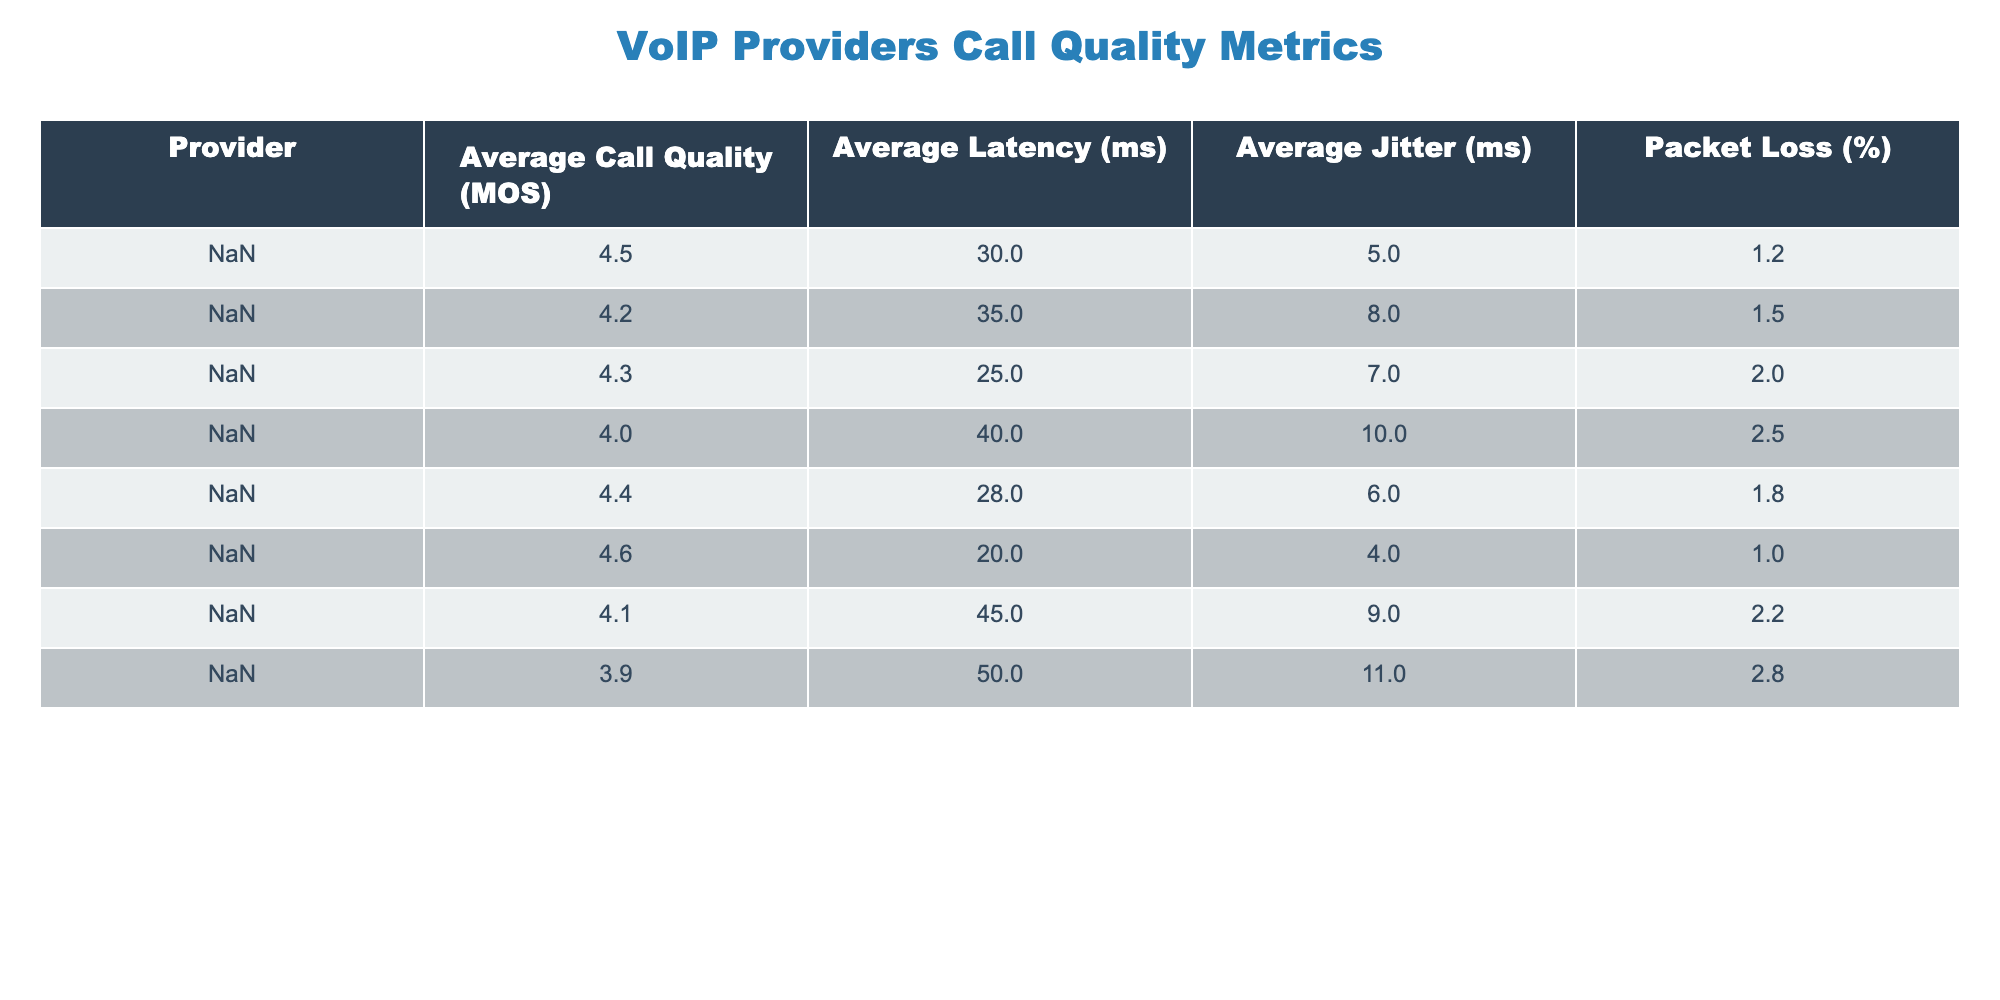What is the average call quality (MOS) of Zoom? According to the table, Zoom has an Average Call Quality (MOS) of 4.5. This value is directly available in the "Average Call Quality (MOS)" column under the Zoom row.
Answer: 4.5 Which VoIP provider has the highest packet loss percentage? The "Packet Loss (%)" column shows that Google Voice has the highest packet loss at 2.8%, as observed in the last row of the table.
Answer: Google Voice What is the average latency of Microsoft Teams? The average latency for Microsoft Teams can be found in the "Average Latency (ms)" column, where it shows a value of 28 milliseconds. This information is directly taken from the corresponding row for Microsoft Teams.
Answer: 28 What is the difference in average call quality between Nextiva and Skype? Nextiva has an Average Call Quality (MOS) of 4.6 and Skype has a MOS of 4.0. To find the difference, subtract the value for Skype from Nextiva: 4.6 - 4.0 = 0.6.
Answer: 0.6 Is the average jitter of RingCentral higher than that of Zoom? In the "Average Jitter (ms)" column, RingCentral shows 8 milliseconds while Zoom shows 5 milliseconds. Comparing these two, 8 is greater than 5, thus the statement is true.
Answer: Yes What is the average packet loss percentage across all listed providers? To find the average packet loss percentage, sum the packet loss values: (1.2 + 1.5 + 2.0 + 2.5 + 1.8 + 1.0 + 2.2 + 2.8) = 12.0, and then divide by the number of providers (8): 12.0 / 8 = 1.5.
Answer: 1.5 Which provider has the lowest average jitter? Looking at the "Average Jitter (ms)" values, Nextiva has the lowest average jitter at 4 milliseconds. This is found by comparing all the entries in that column.
Answer: Nextiva Does any provider have a higher average call quality than 4.5? By checking the "Average Call Quality (MOS)" column, only Nextiva has a MOS of 4.6, which is greater than 4.5. This is a factual check of the values given in the table.
Answer: Yes 